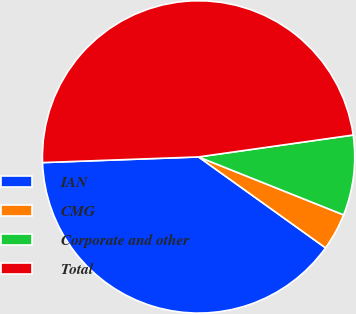Convert chart. <chart><loc_0><loc_0><loc_500><loc_500><pie_chart><fcel>IAN<fcel>CMG<fcel>Corporate and other<fcel>Total<nl><fcel>39.53%<fcel>3.84%<fcel>8.29%<fcel>48.33%<nl></chart> 